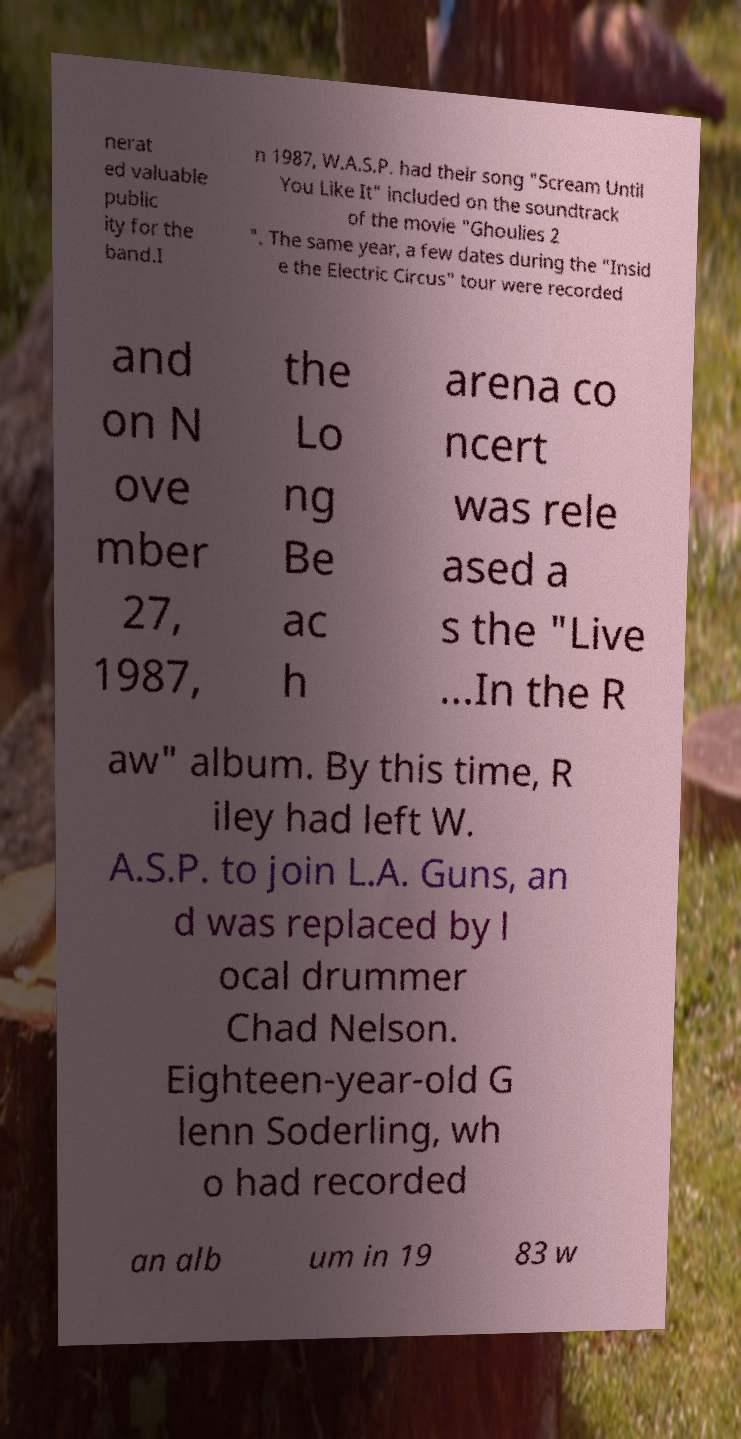For documentation purposes, I need the text within this image transcribed. Could you provide that? nerat ed valuable public ity for the band.I n 1987, W.A.S.P. had their song "Scream Until You Like It" included on the soundtrack of the movie "Ghoulies 2 ". The same year, a few dates during the "Insid e the Electric Circus" tour were recorded and on N ove mber 27, 1987, the Lo ng Be ac h arena co ncert was rele ased a s the "Live ...In the R aw" album. By this time, R iley had left W. A.S.P. to join L.A. Guns, an d was replaced by l ocal drummer Chad Nelson. Eighteen-year-old G lenn Soderling, wh o had recorded an alb um in 19 83 w 